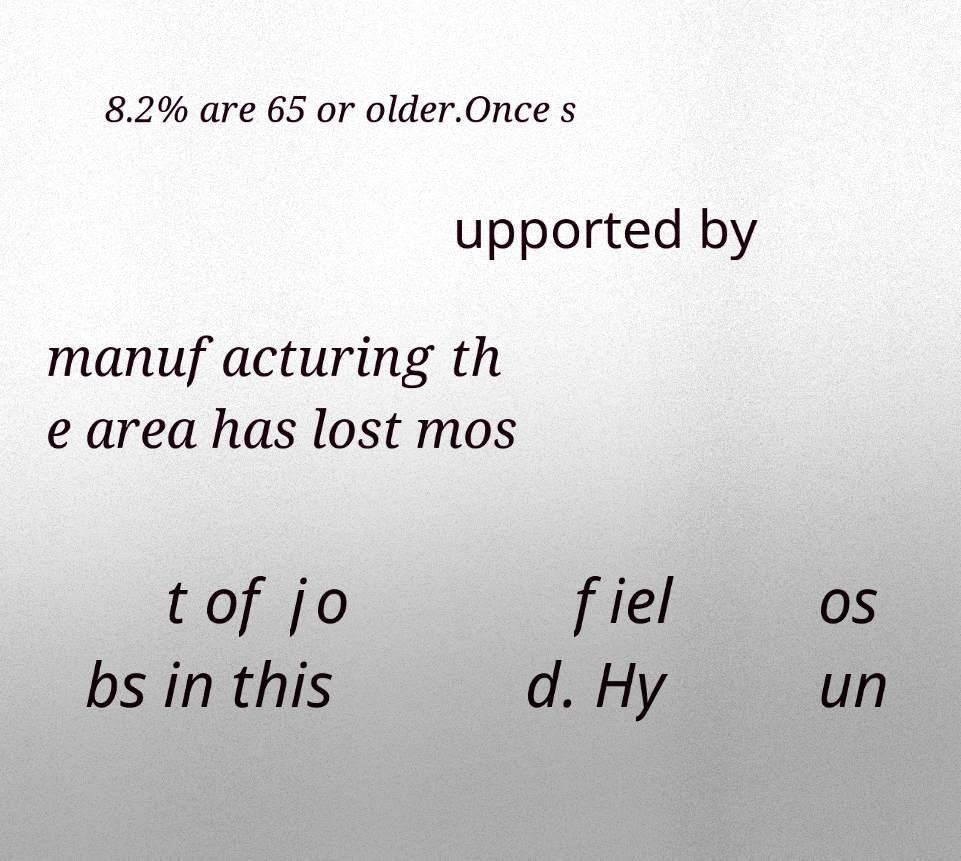Please read and relay the text visible in this image. What does it say? 8.2% are 65 or older.Once s upported by manufacturing th e area has lost mos t of jo bs in this fiel d. Hy os un 